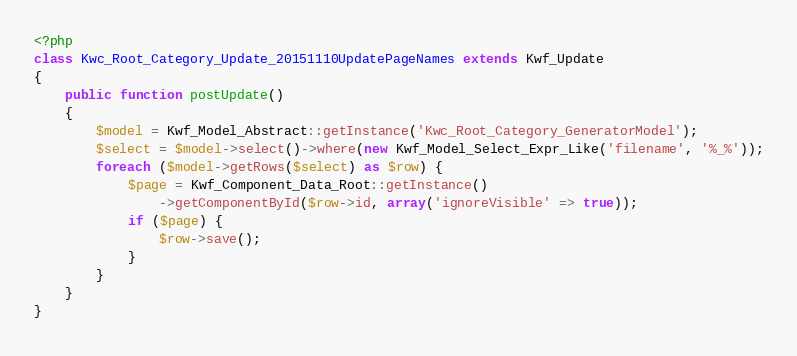Convert code to text. <code><loc_0><loc_0><loc_500><loc_500><_PHP_><?php
class Kwc_Root_Category_Update_20151110UpdatePageNames extends Kwf_Update
{
    public function postUpdate()
    {
        $model = Kwf_Model_Abstract::getInstance('Kwc_Root_Category_GeneratorModel');
        $select = $model->select()->where(new Kwf_Model_Select_Expr_Like('filename', '%_%'));
        foreach ($model->getRows($select) as $row) {
            $page = Kwf_Component_Data_Root::getInstance()
                ->getComponentById($row->id, array('ignoreVisible' => true));
            if ($page) {
                $row->save();
            }
        }
    }
}
</code> 